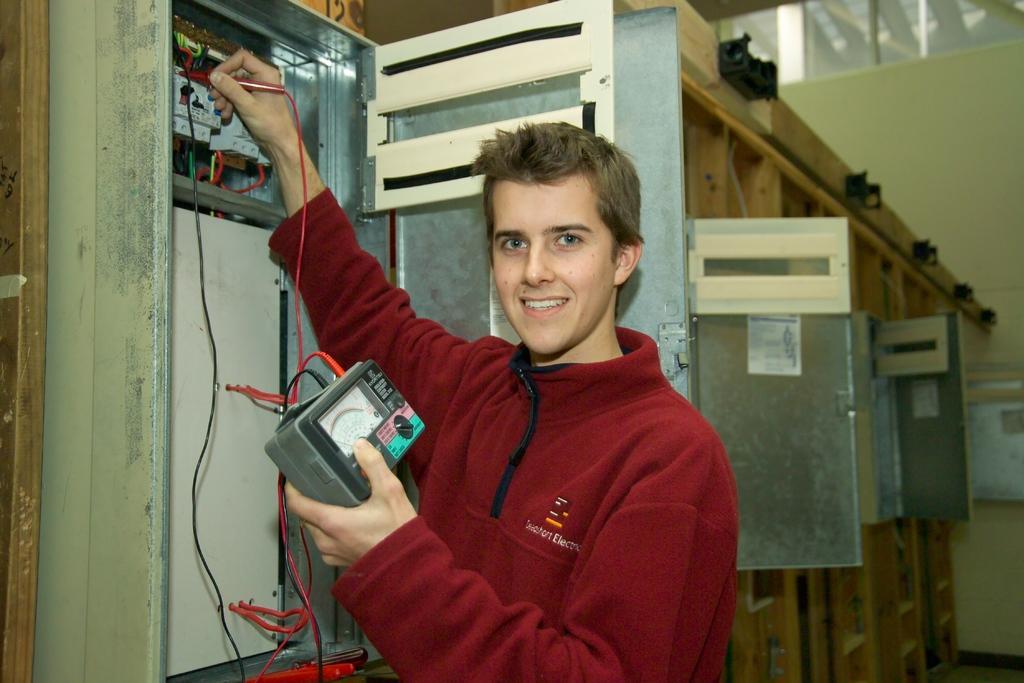In one or two sentences, can you explain what this image depicts? In this image, I can see a man standing and smiling. He is holding a meter with the wires. Behind the man, those are looking like the fuse boxes. 